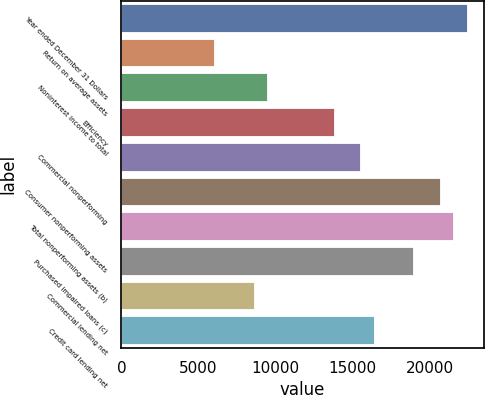Convert chart. <chart><loc_0><loc_0><loc_500><loc_500><bar_chart><fcel>Year ended December 31 Dollars<fcel>Return on average assets<fcel>Noninterest income to total<fcel>Efficiency<fcel>Commercial nonperforming<fcel>Consumer nonperforming assets<fcel>Total nonperforming assets (b)<fcel>Purchased impaired loans (c)<fcel>Commercial lending net<fcel>Credit card lending net<nl><fcel>22372.8<fcel>6023.52<fcel>9465.48<fcel>13767.9<fcel>15488.9<fcel>20651.8<fcel>21512.3<fcel>18930.9<fcel>8604.99<fcel>16349.4<nl></chart> 